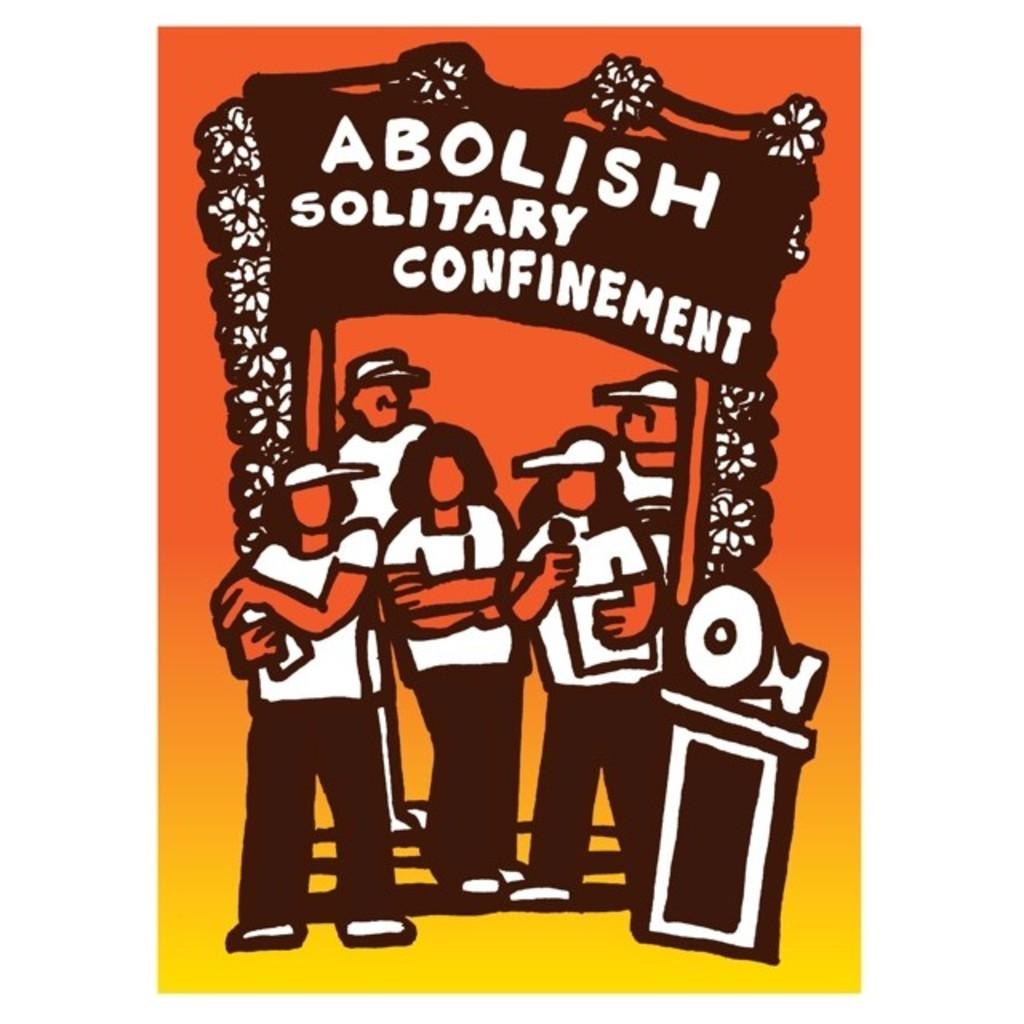Provide a one-sentence caption for the provided image. Five people at an "Abolish Solitary Confinement" rally. 